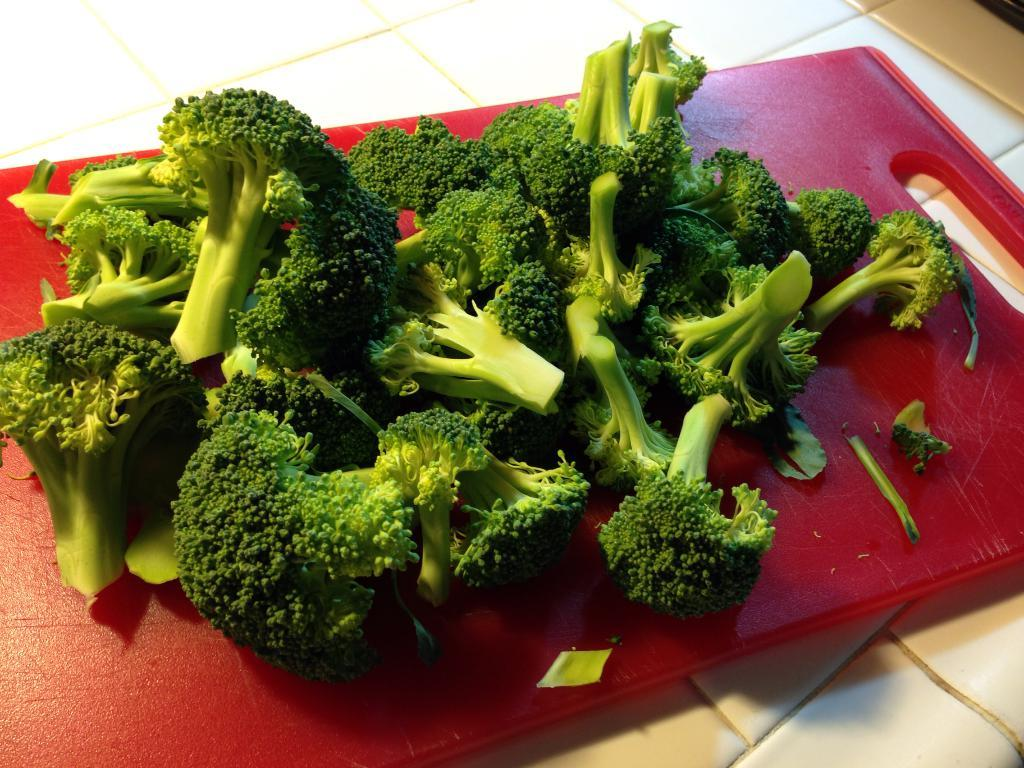What type of vegetable is present in the image? There are broccoli florets in the image. Where are the broccoli florets located? The broccoli florets are placed on a chopping board. What can be seen in the background of the image? There is a surface visible in the background of the image. How long does it take for the broccoli to grow to its current size in the image? The time it takes for broccoli to grow to its current size is not visible in the image, and therefore cannot be determined. 